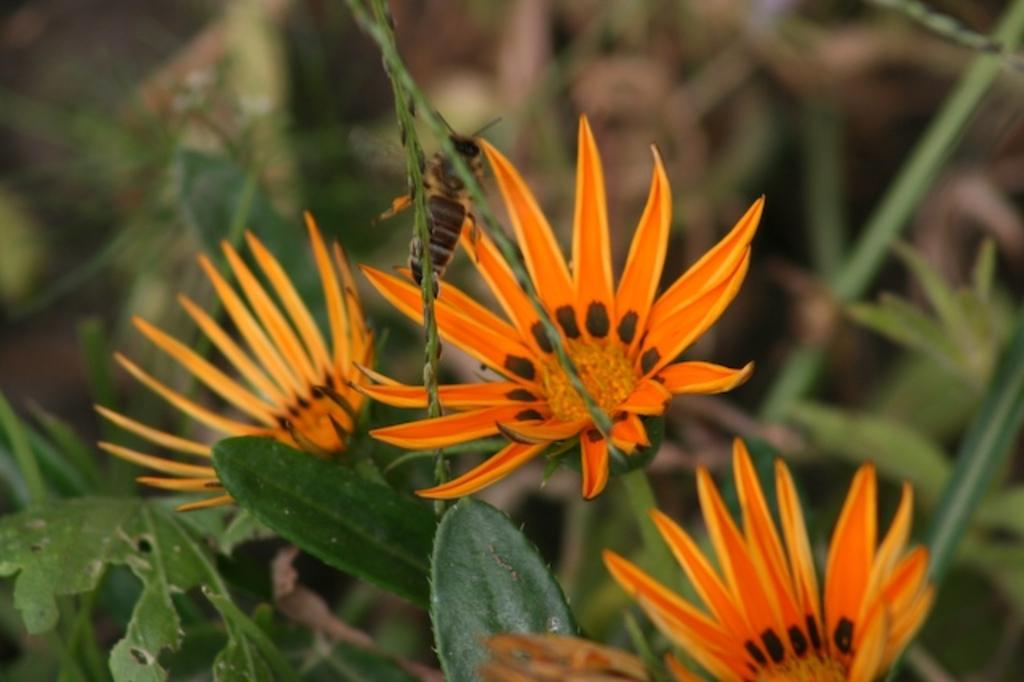What type of flowers can be seen in the image? There are orange colored flowers in the image. Where are the flowers located on the plants? The flowers are present on plants. What other living creature can be seen in the image? There is a bee in the image. Can you describe the location of the bee in the image? The bee is present in the middle of the image. What type of vein is visible on the bee in the image? There is no visible vein on the bee in the image. What type of battle is taking place in the image? There is no battle present in the image; it features flowers, plants, and a bee. 